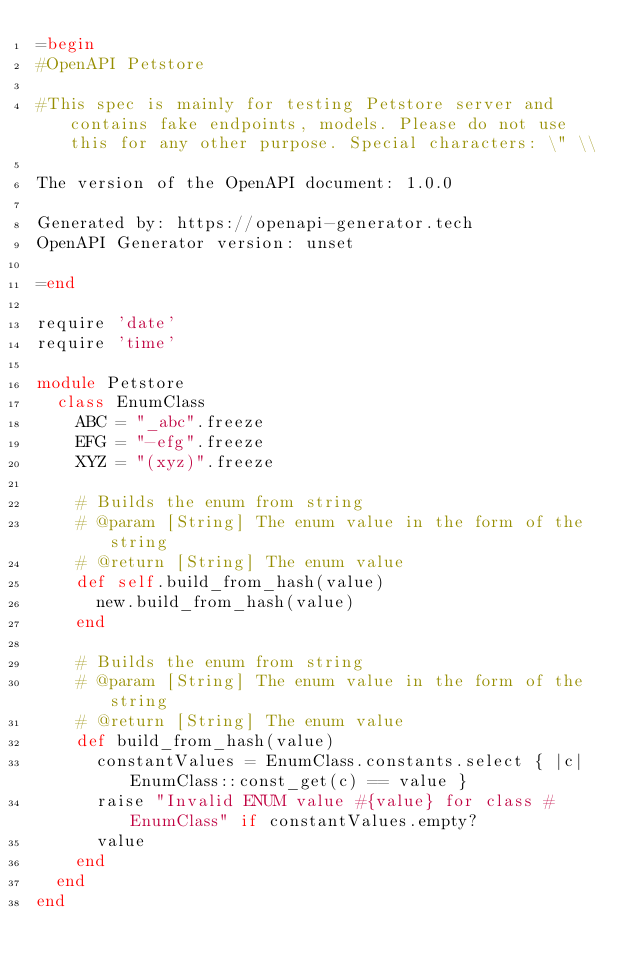Convert code to text. <code><loc_0><loc_0><loc_500><loc_500><_Ruby_>=begin
#OpenAPI Petstore

#This spec is mainly for testing Petstore server and contains fake endpoints, models. Please do not use this for any other purpose. Special characters: \" \\

The version of the OpenAPI document: 1.0.0

Generated by: https://openapi-generator.tech
OpenAPI Generator version: unset

=end

require 'date'
require 'time'

module Petstore
  class EnumClass
    ABC = "_abc".freeze
    EFG = "-efg".freeze
    XYZ = "(xyz)".freeze

    # Builds the enum from string
    # @param [String] The enum value in the form of the string
    # @return [String] The enum value
    def self.build_from_hash(value)
      new.build_from_hash(value)
    end

    # Builds the enum from string
    # @param [String] The enum value in the form of the string
    # @return [String] The enum value
    def build_from_hash(value)
      constantValues = EnumClass.constants.select { |c| EnumClass::const_get(c) == value }
      raise "Invalid ENUM value #{value} for class #EnumClass" if constantValues.empty?
      value
    end
  end
end
</code> 